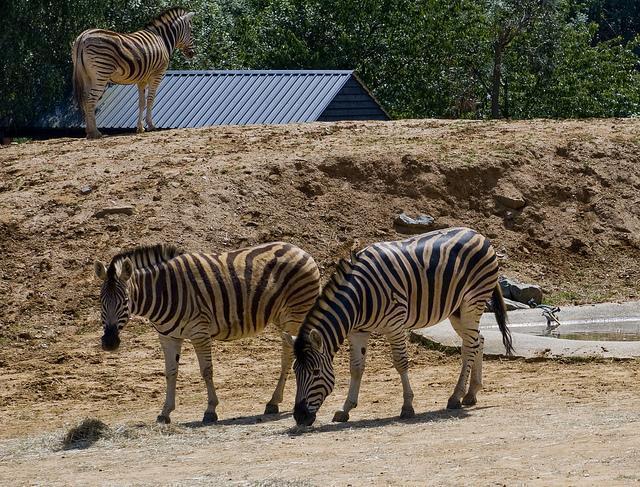How many zebras are walking around on top of the dirt in the courtyard?
Choose the correct response, then elucidate: 'Answer: answer
Rationale: rationale.'
Options: Three, five, one, two. Answer: three.
Rationale: Several black and white striped animals are in an enclosure. 